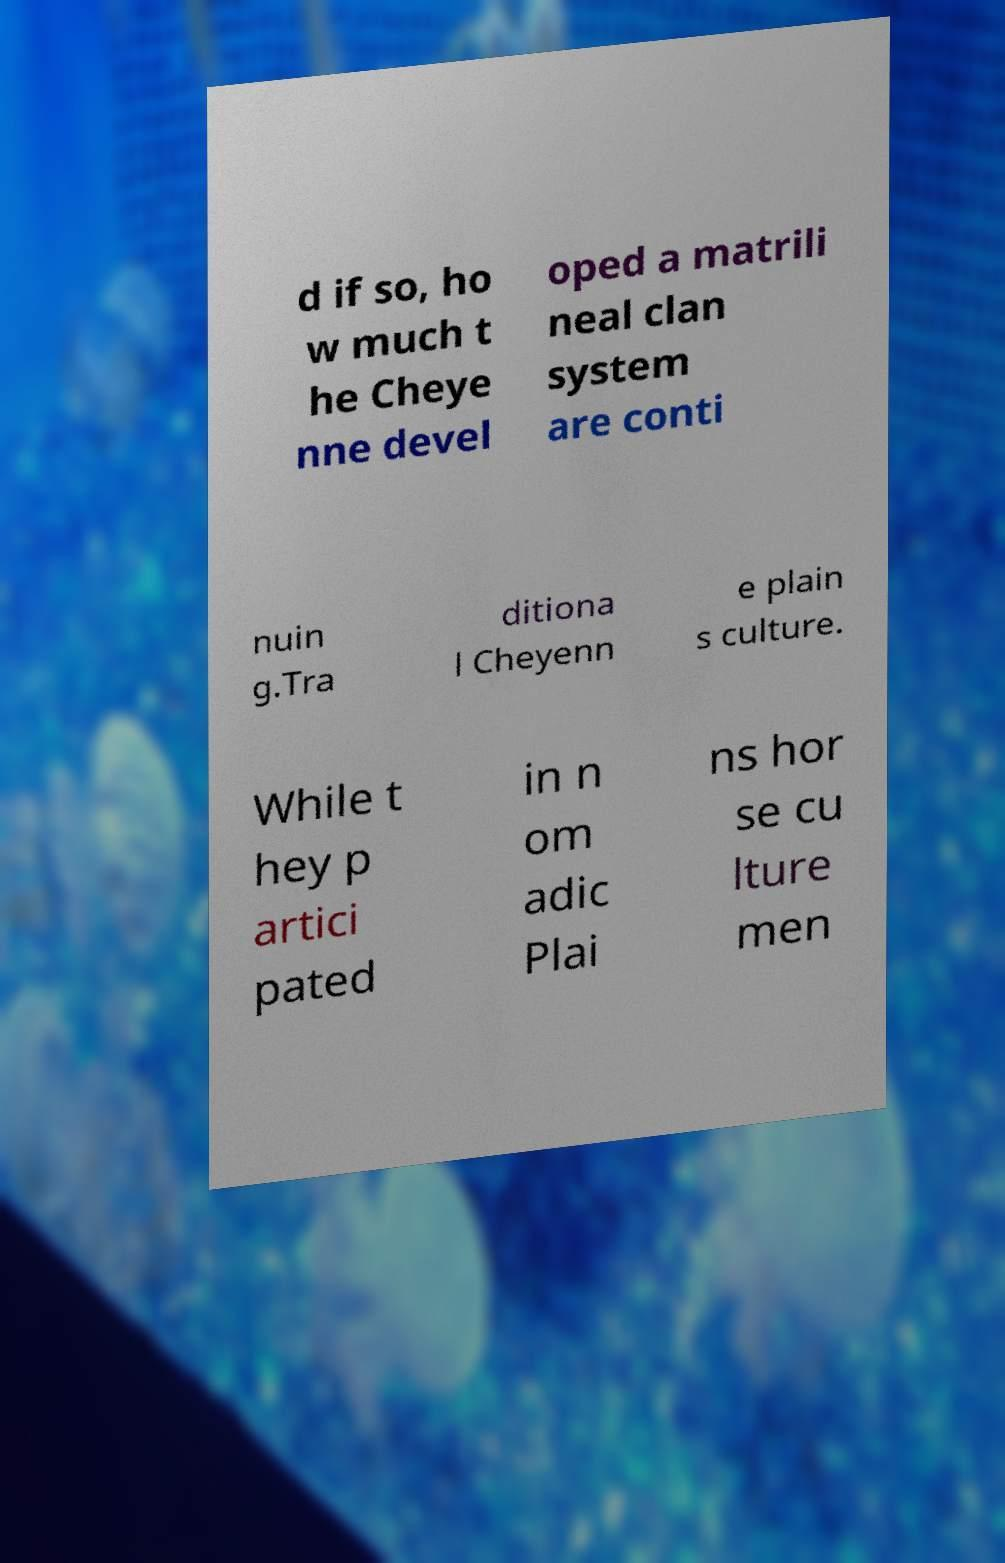For documentation purposes, I need the text within this image transcribed. Could you provide that? d if so, ho w much t he Cheye nne devel oped a matrili neal clan system are conti nuin g.Tra ditiona l Cheyenn e plain s culture. While t hey p artici pated in n om adic Plai ns hor se cu lture men 